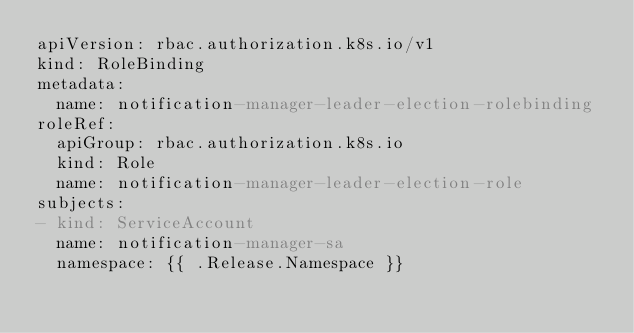Convert code to text. <code><loc_0><loc_0><loc_500><loc_500><_YAML_>apiVersion: rbac.authorization.k8s.io/v1
kind: RoleBinding
metadata:
  name: notification-manager-leader-election-rolebinding
roleRef:
  apiGroup: rbac.authorization.k8s.io
  kind: Role
  name: notification-manager-leader-election-role
subjects:
- kind: ServiceAccount
  name: notification-manager-sa
  namespace: {{ .Release.Namespace }}

  
</code> 